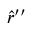<formula> <loc_0><loc_0><loc_500><loc_500>\hat { r } ^ { \prime \prime }</formula> 